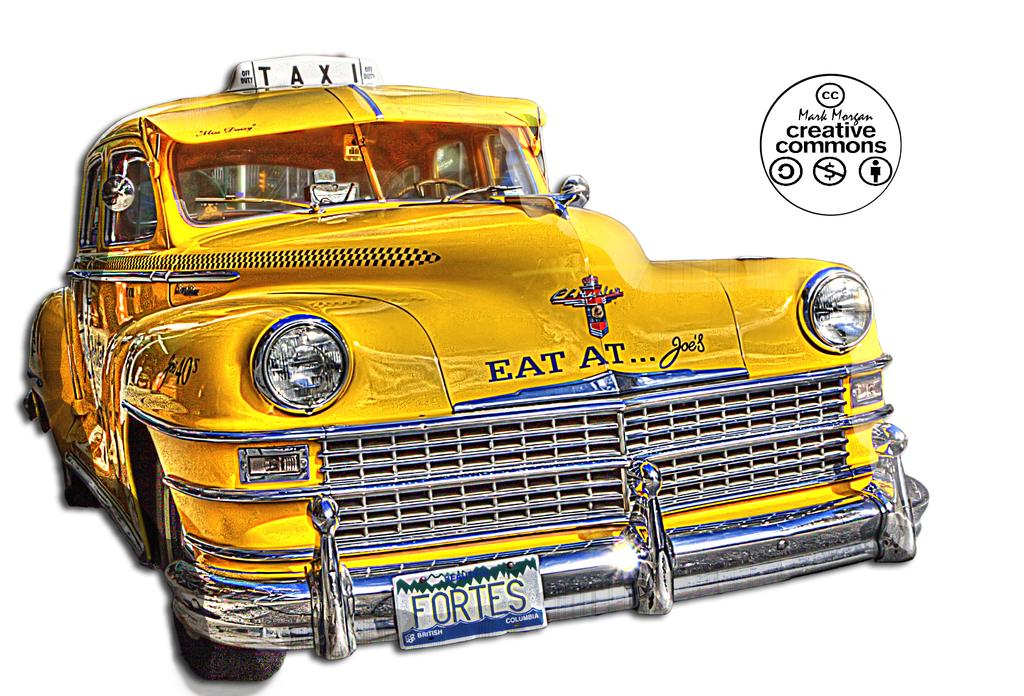Provide a one-sentence caption for the provided image. A yellow taxi that says eat at Joe's on the front bumper. 